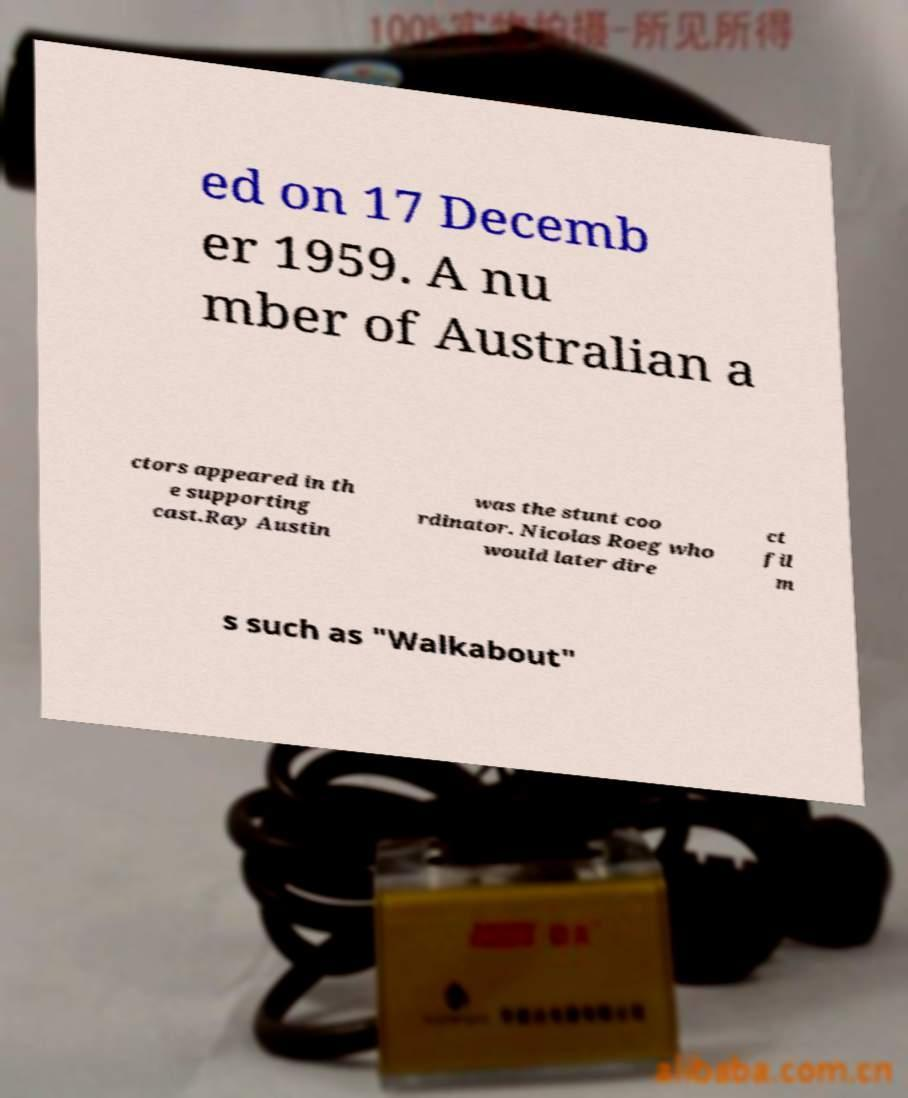What messages or text are displayed in this image? I need them in a readable, typed format. ed on 17 Decemb er 1959. A nu mber of Australian a ctors appeared in th e supporting cast.Ray Austin was the stunt coo rdinator. Nicolas Roeg who would later dire ct fil m s such as "Walkabout" 